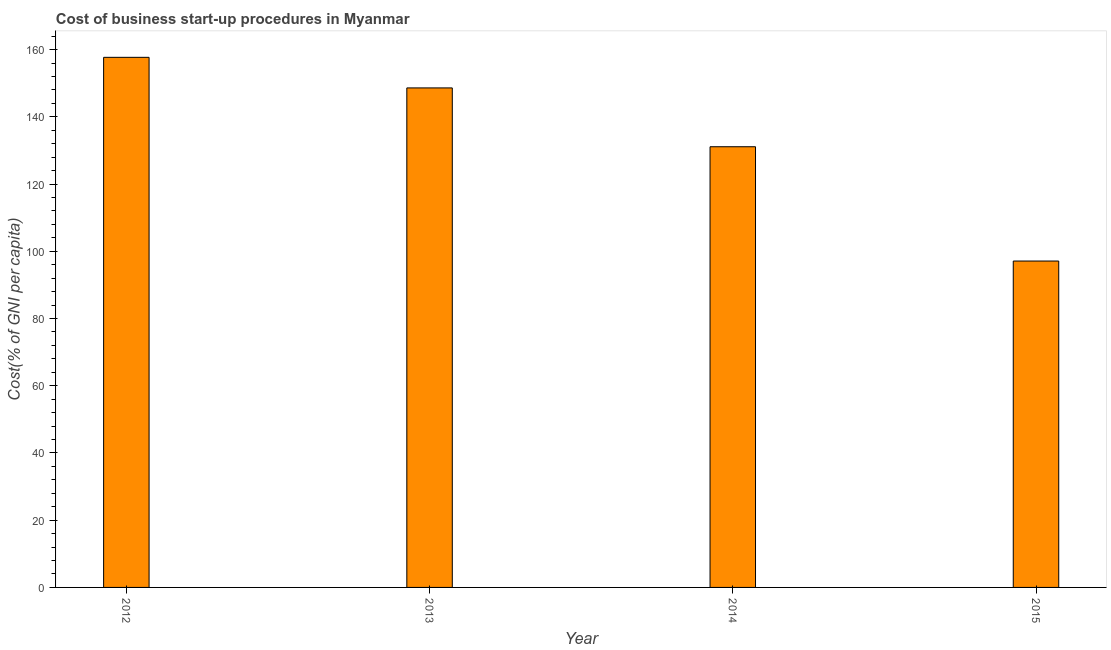Does the graph contain any zero values?
Offer a very short reply. No. Does the graph contain grids?
Your response must be concise. No. What is the title of the graph?
Keep it short and to the point. Cost of business start-up procedures in Myanmar. What is the label or title of the X-axis?
Provide a short and direct response. Year. What is the label or title of the Y-axis?
Offer a very short reply. Cost(% of GNI per capita). What is the cost of business startup procedures in 2014?
Make the answer very short. 131.1. Across all years, what is the maximum cost of business startup procedures?
Ensure brevity in your answer.  157.7. Across all years, what is the minimum cost of business startup procedures?
Give a very brief answer. 97.1. In which year was the cost of business startup procedures maximum?
Your answer should be very brief. 2012. In which year was the cost of business startup procedures minimum?
Your answer should be very brief. 2015. What is the sum of the cost of business startup procedures?
Provide a short and direct response. 534.5. What is the difference between the cost of business startup procedures in 2012 and 2014?
Your answer should be very brief. 26.6. What is the average cost of business startup procedures per year?
Your answer should be very brief. 133.62. What is the median cost of business startup procedures?
Ensure brevity in your answer.  139.85. Do a majority of the years between 2014 and 2013 (inclusive) have cost of business startup procedures greater than 56 %?
Your response must be concise. No. What is the ratio of the cost of business startup procedures in 2012 to that in 2014?
Offer a very short reply. 1.2. Is the difference between the cost of business startup procedures in 2012 and 2014 greater than the difference between any two years?
Give a very brief answer. No. What is the difference between the highest and the second highest cost of business startup procedures?
Offer a very short reply. 9.1. What is the difference between the highest and the lowest cost of business startup procedures?
Offer a very short reply. 60.6. In how many years, is the cost of business startup procedures greater than the average cost of business startup procedures taken over all years?
Ensure brevity in your answer.  2. Are all the bars in the graph horizontal?
Make the answer very short. No. What is the difference between two consecutive major ticks on the Y-axis?
Make the answer very short. 20. Are the values on the major ticks of Y-axis written in scientific E-notation?
Your answer should be very brief. No. What is the Cost(% of GNI per capita) in 2012?
Your answer should be compact. 157.7. What is the Cost(% of GNI per capita) in 2013?
Make the answer very short. 148.6. What is the Cost(% of GNI per capita) of 2014?
Your response must be concise. 131.1. What is the Cost(% of GNI per capita) in 2015?
Make the answer very short. 97.1. What is the difference between the Cost(% of GNI per capita) in 2012 and 2014?
Offer a terse response. 26.6. What is the difference between the Cost(% of GNI per capita) in 2012 and 2015?
Your answer should be compact. 60.6. What is the difference between the Cost(% of GNI per capita) in 2013 and 2014?
Offer a terse response. 17.5. What is the difference between the Cost(% of GNI per capita) in 2013 and 2015?
Offer a terse response. 51.5. What is the difference between the Cost(% of GNI per capita) in 2014 and 2015?
Make the answer very short. 34. What is the ratio of the Cost(% of GNI per capita) in 2012 to that in 2013?
Your answer should be compact. 1.06. What is the ratio of the Cost(% of GNI per capita) in 2012 to that in 2014?
Your answer should be compact. 1.2. What is the ratio of the Cost(% of GNI per capita) in 2012 to that in 2015?
Provide a short and direct response. 1.62. What is the ratio of the Cost(% of GNI per capita) in 2013 to that in 2014?
Offer a very short reply. 1.13. What is the ratio of the Cost(% of GNI per capita) in 2013 to that in 2015?
Your answer should be compact. 1.53. What is the ratio of the Cost(% of GNI per capita) in 2014 to that in 2015?
Your response must be concise. 1.35. 